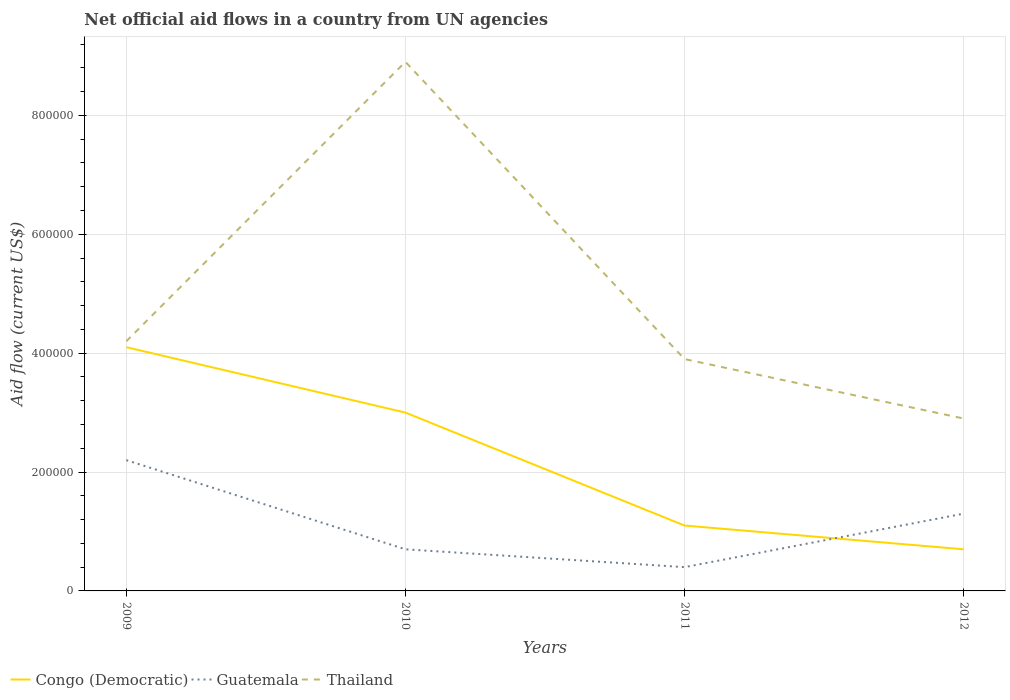Does the line corresponding to Congo (Democratic) intersect with the line corresponding to Thailand?
Your answer should be very brief. No. Is the number of lines equal to the number of legend labels?
Make the answer very short. Yes. Across all years, what is the maximum net official aid flow in Thailand?
Offer a terse response. 2.90e+05. In which year was the net official aid flow in Congo (Democratic) maximum?
Make the answer very short. 2012. What is the total net official aid flow in Congo (Democratic) in the graph?
Keep it short and to the point. 2.30e+05. What is the difference between the highest and the second highest net official aid flow in Congo (Democratic)?
Give a very brief answer. 3.40e+05. Is the net official aid flow in Congo (Democratic) strictly greater than the net official aid flow in Thailand over the years?
Offer a terse response. Yes. How many years are there in the graph?
Give a very brief answer. 4. What is the difference between two consecutive major ticks on the Y-axis?
Ensure brevity in your answer.  2.00e+05. Does the graph contain any zero values?
Your response must be concise. No. What is the title of the graph?
Offer a terse response. Net official aid flows in a country from UN agencies. Does "High income: nonOECD" appear as one of the legend labels in the graph?
Keep it short and to the point. No. What is the label or title of the X-axis?
Make the answer very short. Years. What is the label or title of the Y-axis?
Your answer should be compact. Aid flow (current US$). What is the Aid flow (current US$) of Congo (Democratic) in 2009?
Provide a short and direct response. 4.10e+05. What is the Aid flow (current US$) of Guatemala in 2009?
Make the answer very short. 2.20e+05. What is the Aid flow (current US$) of Thailand in 2009?
Provide a succinct answer. 4.20e+05. What is the Aid flow (current US$) of Congo (Democratic) in 2010?
Give a very brief answer. 3.00e+05. What is the Aid flow (current US$) in Guatemala in 2010?
Your answer should be very brief. 7.00e+04. What is the Aid flow (current US$) of Thailand in 2010?
Make the answer very short. 8.90e+05. What is the Aid flow (current US$) of Guatemala in 2011?
Provide a succinct answer. 4.00e+04. What is the Aid flow (current US$) in Thailand in 2011?
Make the answer very short. 3.90e+05. Across all years, what is the maximum Aid flow (current US$) in Thailand?
Your answer should be compact. 8.90e+05. Across all years, what is the minimum Aid flow (current US$) of Congo (Democratic)?
Provide a short and direct response. 7.00e+04. Across all years, what is the minimum Aid flow (current US$) in Guatemala?
Provide a short and direct response. 4.00e+04. What is the total Aid flow (current US$) of Congo (Democratic) in the graph?
Your answer should be very brief. 8.90e+05. What is the total Aid flow (current US$) of Thailand in the graph?
Ensure brevity in your answer.  1.99e+06. What is the difference between the Aid flow (current US$) in Congo (Democratic) in 2009 and that in 2010?
Offer a very short reply. 1.10e+05. What is the difference between the Aid flow (current US$) of Thailand in 2009 and that in 2010?
Your response must be concise. -4.70e+05. What is the difference between the Aid flow (current US$) in Guatemala in 2009 and that in 2011?
Your answer should be very brief. 1.80e+05. What is the difference between the Aid flow (current US$) of Thailand in 2009 and that in 2011?
Keep it short and to the point. 3.00e+04. What is the difference between the Aid flow (current US$) in Congo (Democratic) in 2009 and that in 2012?
Offer a very short reply. 3.40e+05. What is the difference between the Aid flow (current US$) of Guatemala in 2009 and that in 2012?
Provide a succinct answer. 9.00e+04. What is the difference between the Aid flow (current US$) of Congo (Democratic) in 2010 and that in 2011?
Provide a short and direct response. 1.90e+05. What is the difference between the Aid flow (current US$) in Guatemala in 2010 and that in 2011?
Your answer should be very brief. 3.00e+04. What is the difference between the Aid flow (current US$) in Thailand in 2010 and that in 2011?
Make the answer very short. 5.00e+05. What is the difference between the Aid flow (current US$) of Guatemala in 2010 and that in 2012?
Offer a very short reply. -6.00e+04. What is the difference between the Aid flow (current US$) of Congo (Democratic) in 2011 and that in 2012?
Keep it short and to the point. 4.00e+04. What is the difference between the Aid flow (current US$) of Congo (Democratic) in 2009 and the Aid flow (current US$) of Thailand in 2010?
Your answer should be compact. -4.80e+05. What is the difference between the Aid flow (current US$) in Guatemala in 2009 and the Aid flow (current US$) in Thailand in 2010?
Offer a terse response. -6.70e+05. What is the difference between the Aid flow (current US$) in Congo (Democratic) in 2009 and the Aid flow (current US$) in Thailand in 2011?
Ensure brevity in your answer.  2.00e+04. What is the difference between the Aid flow (current US$) in Congo (Democratic) in 2010 and the Aid flow (current US$) in Thailand in 2011?
Your answer should be very brief. -9.00e+04. What is the difference between the Aid flow (current US$) of Guatemala in 2010 and the Aid flow (current US$) of Thailand in 2011?
Provide a short and direct response. -3.20e+05. What is the difference between the Aid flow (current US$) of Congo (Democratic) in 2010 and the Aid flow (current US$) of Thailand in 2012?
Keep it short and to the point. 10000. What is the difference between the Aid flow (current US$) in Guatemala in 2010 and the Aid flow (current US$) in Thailand in 2012?
Give a very brief answer. -2.20e+05. What is the difference between the Aid flow (current US$) of Guatemala in 2011 and the Aid flow (current US$) of Thailand in 2012?
Keep it short and to the point. -2.50e+05. What is the average Aid flow (current US$) of Congo (Democratic) per year?
Your answer should be compact. 2.22e+05. What is the average Aid flow (current US$) of Guatemala per year?
Offer a very short reply. 1.15e+05. What is the average Aid flow (current US$) of Thailand per year?
Provide a succinct answer. 4.98e+05. In the year 2009, what is the difference between the Aid flow (current US$) in Guatemala and Aid flow (current US$) in Thailand?
Your answer should be very brief. -2.00e+05. In the year 2010, what is the difference between the Aid flow (current US$) in Congo (Democratic) and Aid flow (current US$) in Thailand?
Offer a very short reply. -5.90e+05. In the year 2010, what is the difference between the Aid flow (current US$) in Guatemala and Aid flow (current US$) in Thailand?
Offer a very short reply. -8.20e+05. In the year 2011, what is the difference between the Aid flow (current US$) in Congo (Democratic) and Aid flow (current US$) in Thailand?
Keep it short and to the point. -2.80e+05. In the year 2011, what is the difference between the Aid flow (current US$) of Guatemala and Aid flow (current US$) of Thailand?
Give a very brief answer. -3.50e+05. In the year 2012, what is the difference between the Aid flow (current US$) of Congo (Democratic) and Aid flow (current US$) of Guatemala?
Your response must be concise. -6.00e+04. In the year 2012, what is the difference between the Aid flow (current US$) of Congo (Democratic) and Aid flow (current US$) of Thailand?
Keep it short and to the point. -2.20e+05. In the year 2012, what is the difference between the Aid flow (current US$) of Guatemala and Aid flow (current US$) of Thailand?
Offer a very short reply. -1.60e+05. What is the ratio of the Aid flow (current US$) of Congo (Democratic) in 2009 to that in 2010?
Offer a terse response. 1.37. What is the ratio of the Aid flow (current US$) in Guatemala in 2009 to that in 2010?
Offer a very short reply. 3.14. What is the ratio of the Aid flow (current US$) in Thailand in 2009 to that in 2010?
Make the answer very short. 0.47. What is the ratio of the Aid flow (current US$) in Congo (Democratic) in 2009 to that in 2011?
Offer a very short reply. 3.73. What is the ratio of the Aid flow (current US$) of Guatemala in 2009 to that in 2011?
Offer a terse response. 5.5. What is the ratio of the Aid flow (current US$) in Thailand in 2009 to that in 2011?
Ensure brevity in your answer.  1.08. What is the ratio of the Aid flow (current US$) of Congo (Democratic) in 2009 to that in 2012?
Offer a terse response. 5.86. What is the ratio of the Aid flow (current US$) of Guatemala in 2009 to that in 2012?
Give a very brief answer. 1.69. What is the ratio of the Aid flow (current US$) of Thailand in 2009 to that in 2012?
Give a very brief answer. 1.45. What is the ratio of the Aid flow (current US$) of Congo (Democratic) in 2010 to that in 2011?
Your response must be concise. 2.73. What is the ratio of the Aid flow (current US$) in Guatemala in 2010 to that in 2011?
Your response must be concise. 1.75. What is the ratio of the Aid flow (current US$) of Thailand in 2010 to that in 2011?
Offer a very short reply. 2.28. What is the ratio of the Aid flow (current US$) of Congo (Democratic) in 2010 to that in 2012?
Make the answer very short. 4.29. What is the ratio of the Aid flow (current US$) of Guatemala in 2010 to that in 2012?
Your answer should be very brief. 0.54. What is the ratio of the Aid flow (current US$) in Thailand in 2010 to that in 2012?
Ensure brevity in your answer.  3.07. What is the ratio of the Aid flow (current US$) of Congo (Democratic) in 2011 to that in 2012?
Make the answer very short. 1.57. What is the ratio of the Aid flow (current US$) of Guatemala in 2011 to that in 2012?
Your response must be concise. 0.31. What is the ratio of the Aid flow (current US$) in Thailand in 2011 to that in 2012?
Provide a short and direct response. 1.34. What is the difference between the highest and the second highest Aid flow (current US$) of Guatemala?
Keep it short and to the point. 9.00e+04. What is the difference between the highest and the second highest Aid flow (current US$) of Thailand?
Offer a very short reply. 4.70e+05. What is the difference between the highest and the lowest Aid flow (current US$) of Guatemala?
Your response must be concise. 1.80e+05. What is the difference between the highest and the lowest Aid flow (current US$) of Thailand?
Ensure brevity in your answer.  6.00e+05. 